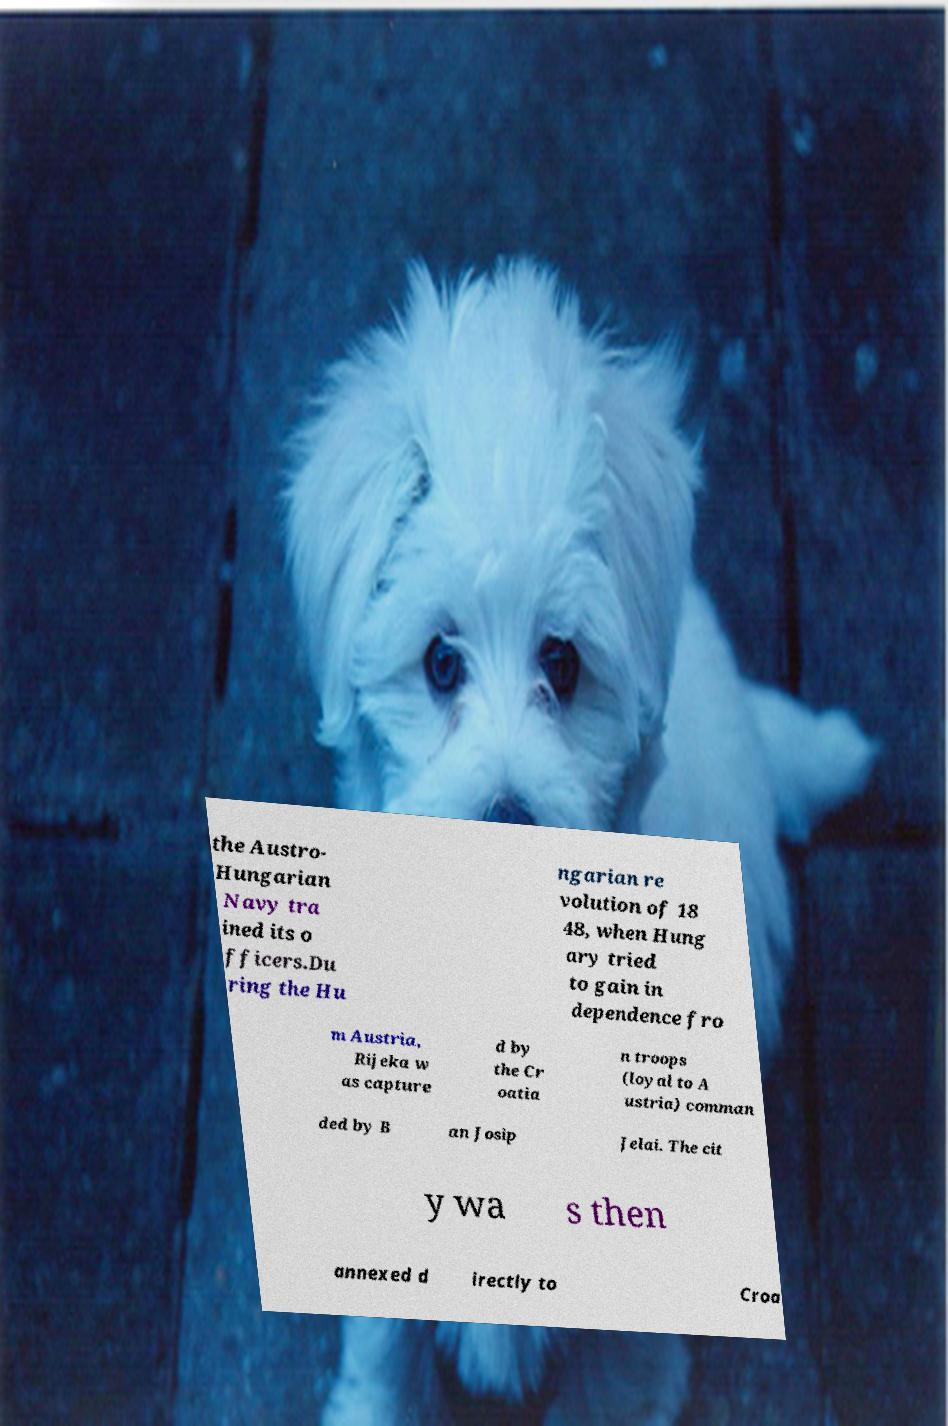I need the written content from this picture converted into text. Can you do that? the Austro- Hungarian Navy tra ined its o fficers.Du ring the Hu ngarian re volution of 18 48, when Hung ary tried to gain in dependence fro m Austria, Rijeka w as capture d by the Cr oatia n troops (loyal to A ustria) comman ded by B an Josip Jelai. The cit y wa s then annexed d irectly to Croa 